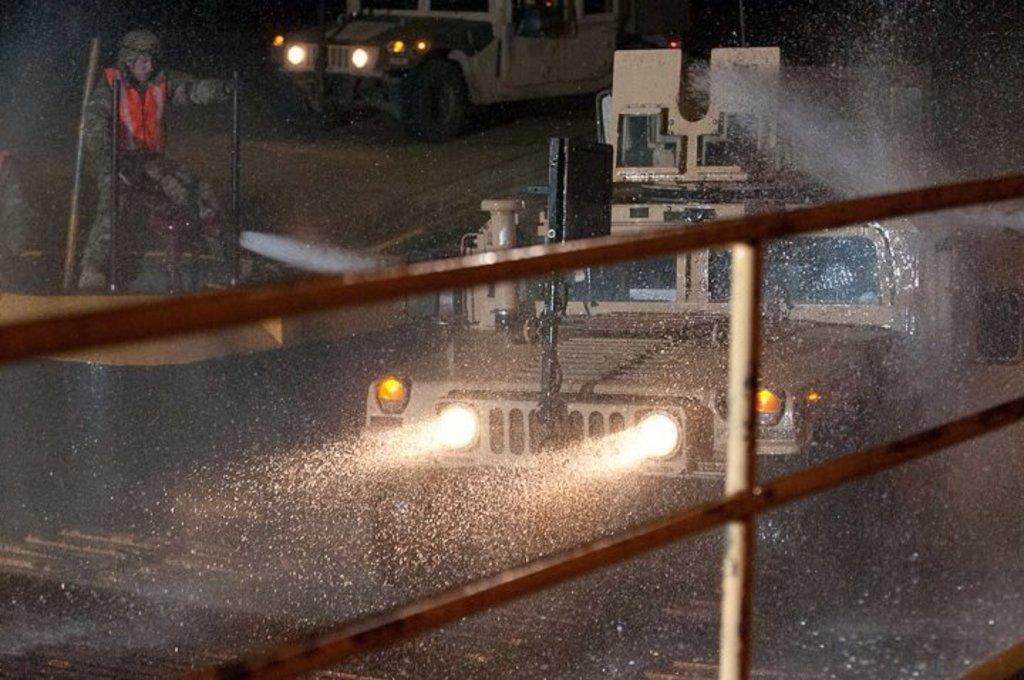What objects can be seen in the image that are made of metal? There are iron rods in the image. What type of transportation is visible on the road in the image? There are vehicles on the road in the image. Can you describe the person in the image? The person is standing and holding a water pipe. What is the person doing with the water pipe? The person is doing something with the water pipe, but the specific action is not clear from the image. What color crayon is the actor using in the image? There is no actor or crayon present in the image. 